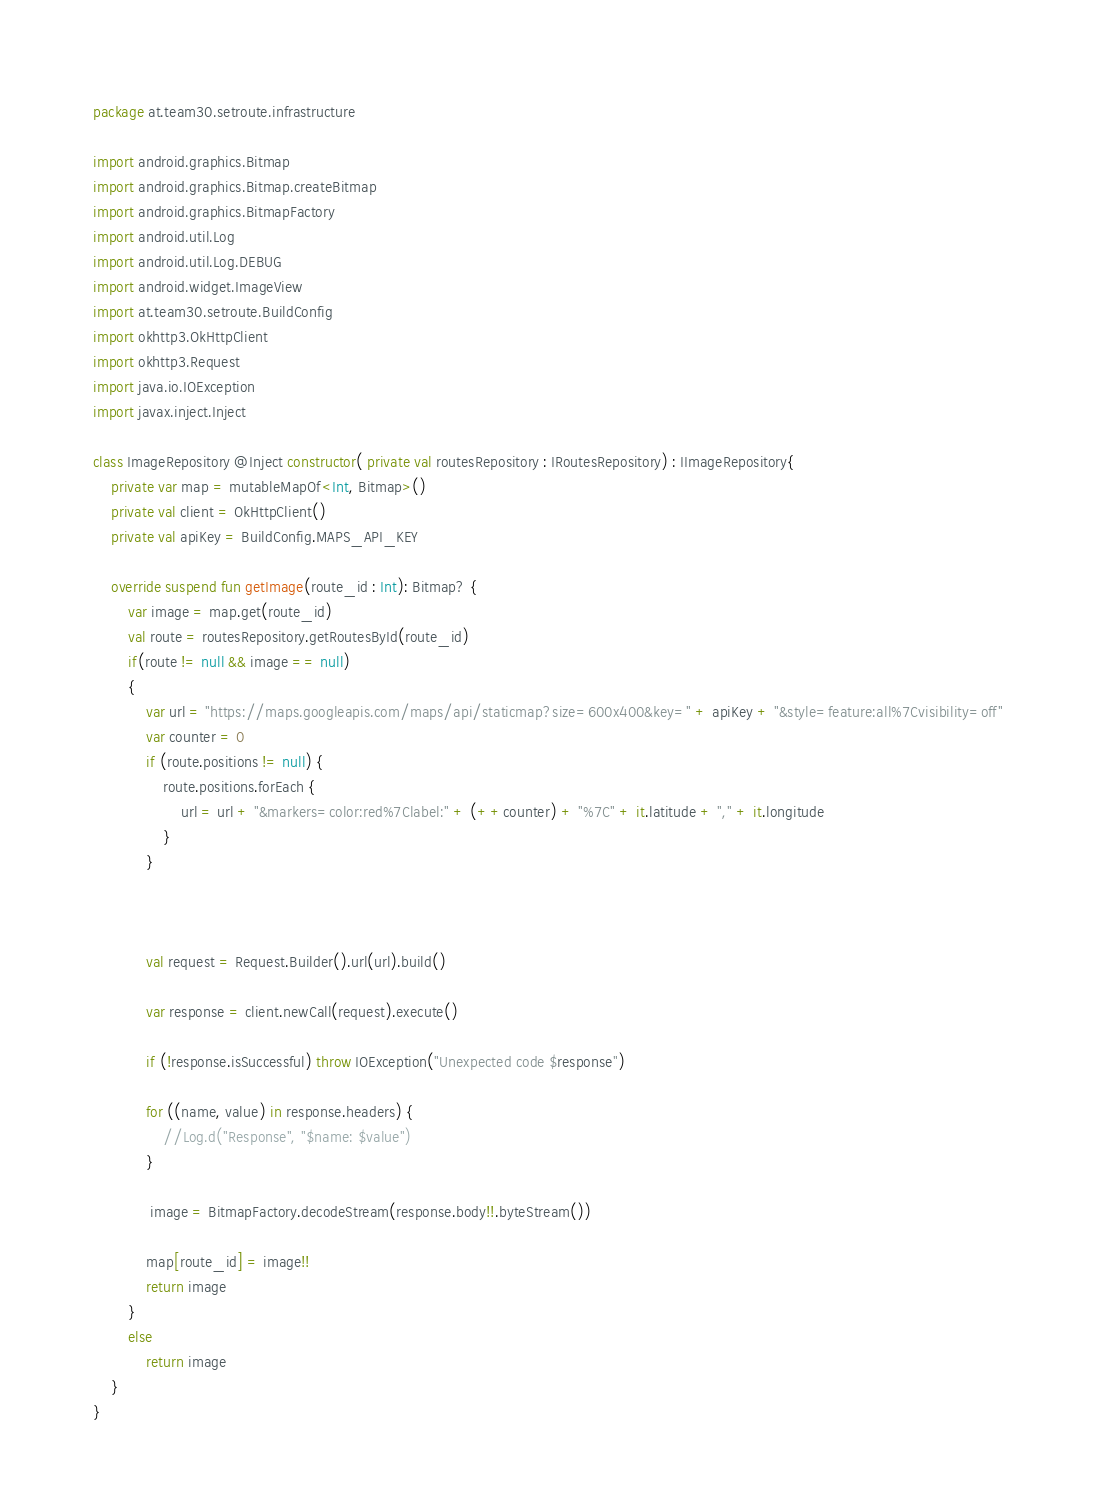Convert code to text. <code><loc_0><loc_0><loc_500><loc_500><_Kotlin_>package at.team30.setroute.infrastructure

import android.graphics.Bitmap
import android.graphics.Bitmap.createBitmap
import android.graphics.BitmapFactory
import android.util.Log
import android.util.Log.DEBUG
import android.widget.ImageView
import at.team30.setroute.BuildConfig
import okhttp3.OkHttpClient
import okhttp3.Request
import java.io.IOException
import javax.inject.Inject

class ImageRepository @Inject constructor( private val routesRepository : IRoutesRepository) : IImageRepository{
    private var map = mutableMapOf<Int, Bitmap>()
    private val client = OkHttpClient()
    private val apiKey = BuildConfig.MAPS_API_KEY

    override suspend fun getImage(route_id : Int): Bitmap? {
        var image = map.get(route_id)
        val route = routesRepository.getRoutesById(route_id)
        if(route != null && image == null)
        {
            var url = "https://maps.googleapis.com/maps/api/staticmap?size=600x400&key=" + apiKey + "&style=feature:all%7Cvisibility=off"
            var counter = 0
            if (route.positions != null) {
                route.positions.forEach {
                    url = url + "&markers=color:red%7Clabel:" + (++counter) + "%7C" + it.latitude + "," + it.longitude
                }
            }



            val request = Request.Builder().url(url).build()

            var response = client.newCall(request).execute()

            if (!response.isSuccessful) throw IOException("Unexpected code $response")

            for ((name, value) in response.headers) {
                //Log.d("Response", "$name: $value")
            }

             image = BitmapFactory.decodeStream(response.body!!.byteStream())

            map[route_id] = image!!
            return image
        }
        else
            return image
    }
}</code> 